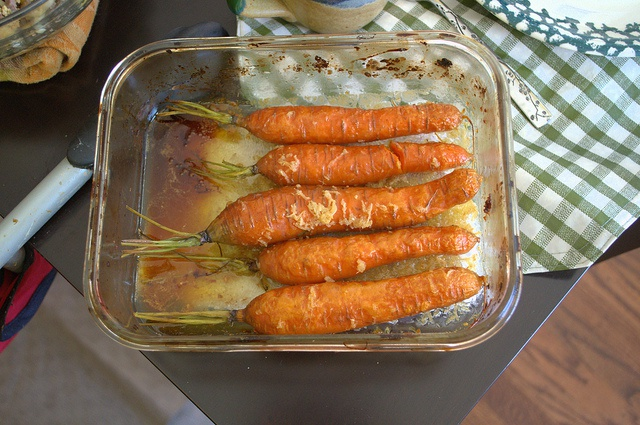Describe the objects in this image and their specific colors. I can see bowl in olive, brown, maroon, red, and tan tones, carrot in olive, red, brown, and tan tones, carrot in olive, red, and orange tones, carrot in olive, red, brown, and orange tones, and carrot in olive, red, brown, tan, and maroon tones in this image. 